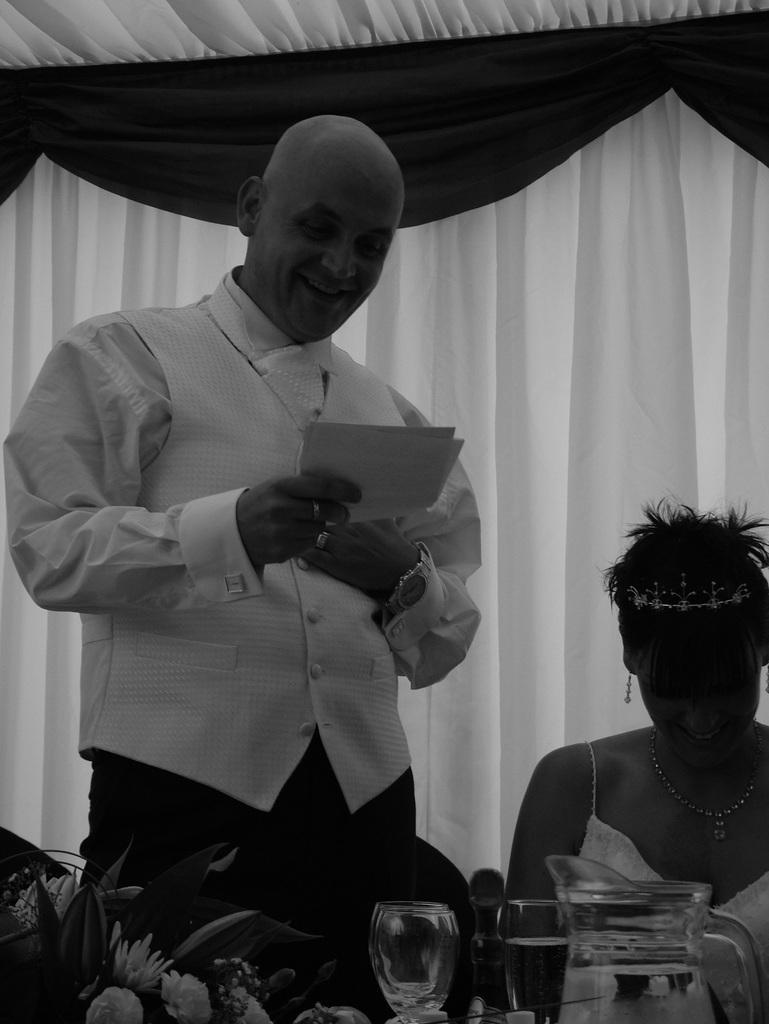Describe this image in one or two sentences. In this image I can see the person is standing and holding something and another person is sitting. I can see few flowers, glasses, jar and the curtain. The image is in black and white. 